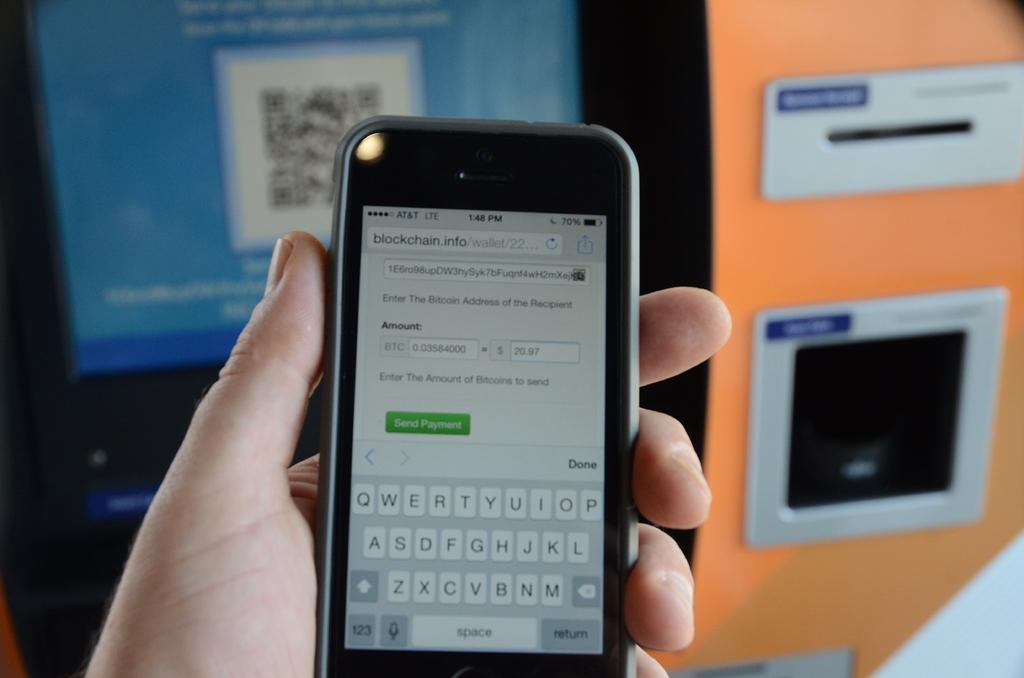Provide a one-sentence caption for the provided image. An iphone displaying a blockchain website on it. 